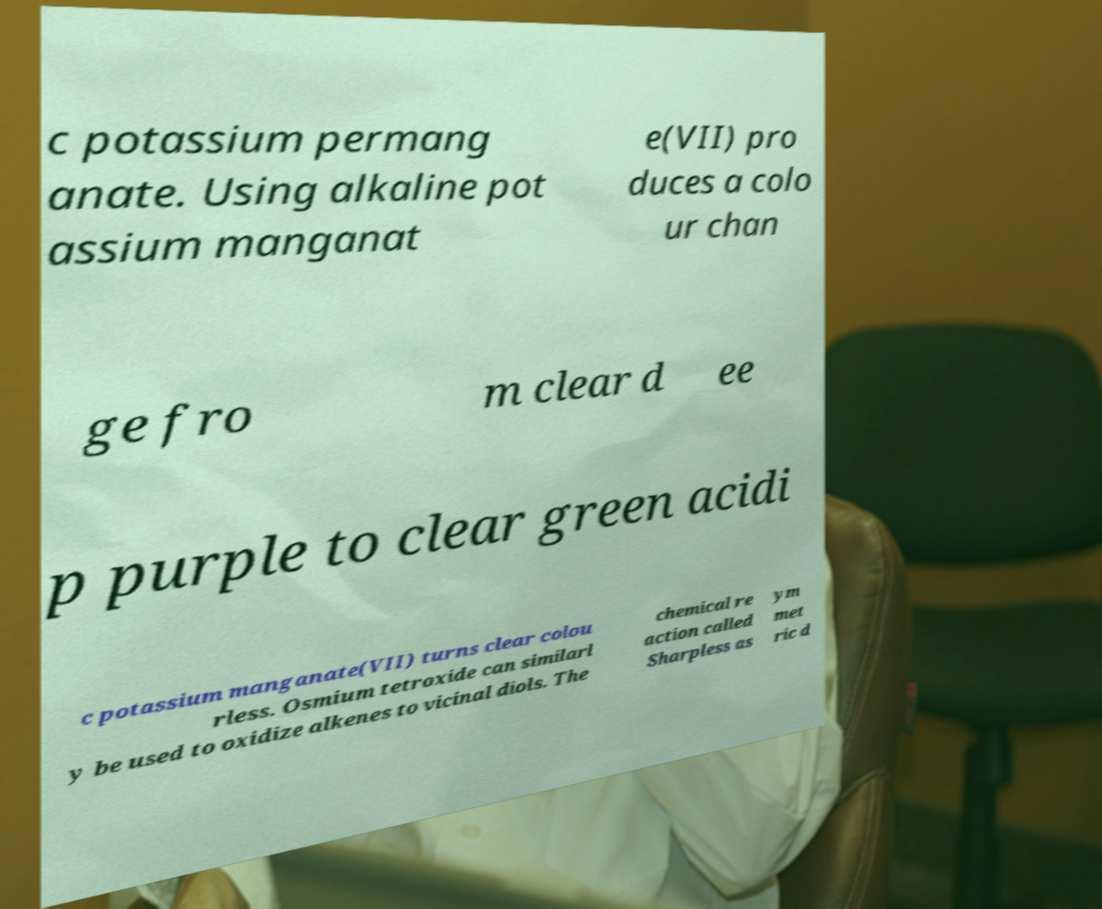There's text embedded in this image that I need extracted. Can you transcribe it verbatim? c potassium permang anate. Using alkaline pot assium manganat e(VII) pro duces a colo ur chan ge fro m clear d ee p purple to clear green acidi c potassium manganate(VII) turns clear colou rless. Osmium tetroxide can similarl y be used to oxidize alkenes to vicinal diols. The chemical re action called Sharpless as ym met ric d 